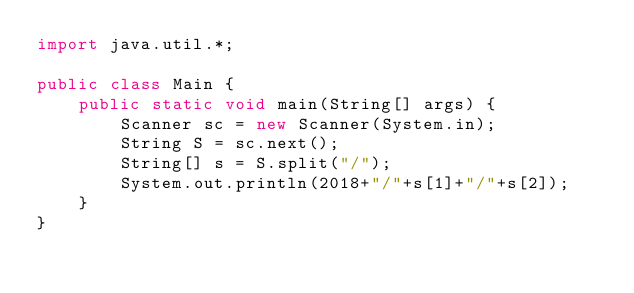<code> <loc_0><loc_0><loc_500><loc_500><_Java_>import java.util.*;
 
public class Main {
    public static void main(String[] args) {
    	Scanner sc = new Scanner(System.in);
    	String S = sc.next();
    	String[] s = S.split("/");
    	System.out.println(2018+"/"+s[1]+"/"+s[2]);
    }
}</code> 